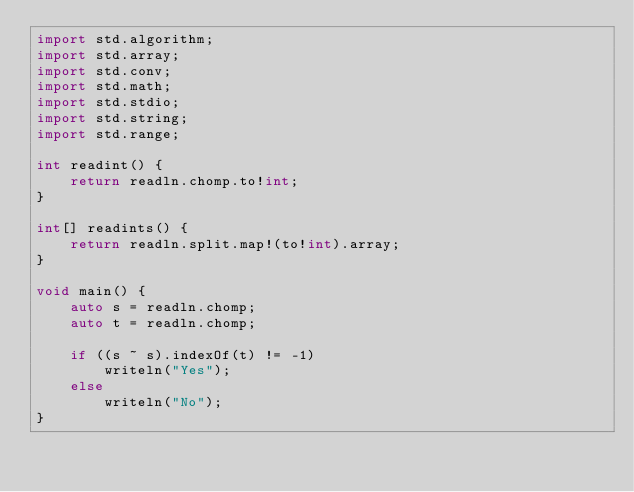<code> <loc_0><loc_0><loc_500><loc_500><_D_>import std.algorithm;
import std.array;
import std.conv;
import std.math;
import std.stdio;
import std.string;
import std.range;

int readint() {
    return readln.chomp.to!int;
}

int[] readints() {
    return readln.split.map!(to!int).array;
}

void main() {
    auto s = readln.chomp;
    auto t = readln.chomp;

    if ((s ~ s).indexOf(t) != -1)
        writeln("Yes");
    else
        writeln("No");
}</code> 